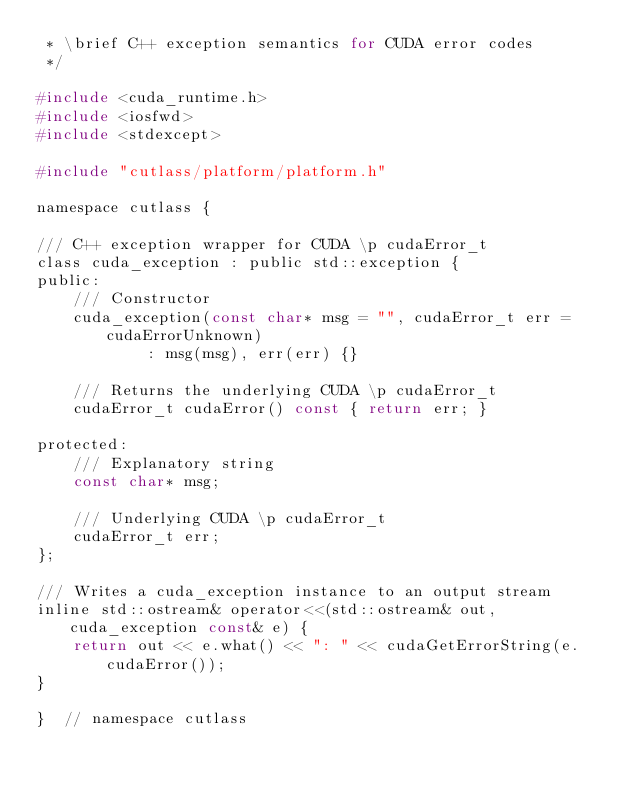Convert code to text. <code><loc_0><loc_0><loc_500><loc_500><_C_> * \brief C++ exception semantics for CUDA error codes
 */

#include <cuda_runtime.h>
#include <iosfwd>
#include <stdexcept>

#include "cutlass/platform/platform.h"

namespace cutlass {

/// C++ exception wrapper for CUDA \p cudaError_t
class cuda_exception : public std::exception {
public:
    /// Constructor
    cuda_exception(const char* msg = "", cudaError_t err = cudaErrorUnknown)
            : msg(msg), err(err) {}

    /// Returns the underlying CUDA \p cudaError_t
    cudaError_t cudaError() const { return err; }

protected:
    /// Explanatory string
    const char* msg;

    /// Underlying CUDA \p cudaError_t
    cudaError_t err;
};

/// Writes a cuda_exception instance to an output stream
inline std::ostream& operator<<(std::ostream& out, cuda_exception const& e) {
    return out << e.what() << ": " << cudaGetErrorString(e.cudaError());
}

}  // namespace cutlass
</code> 